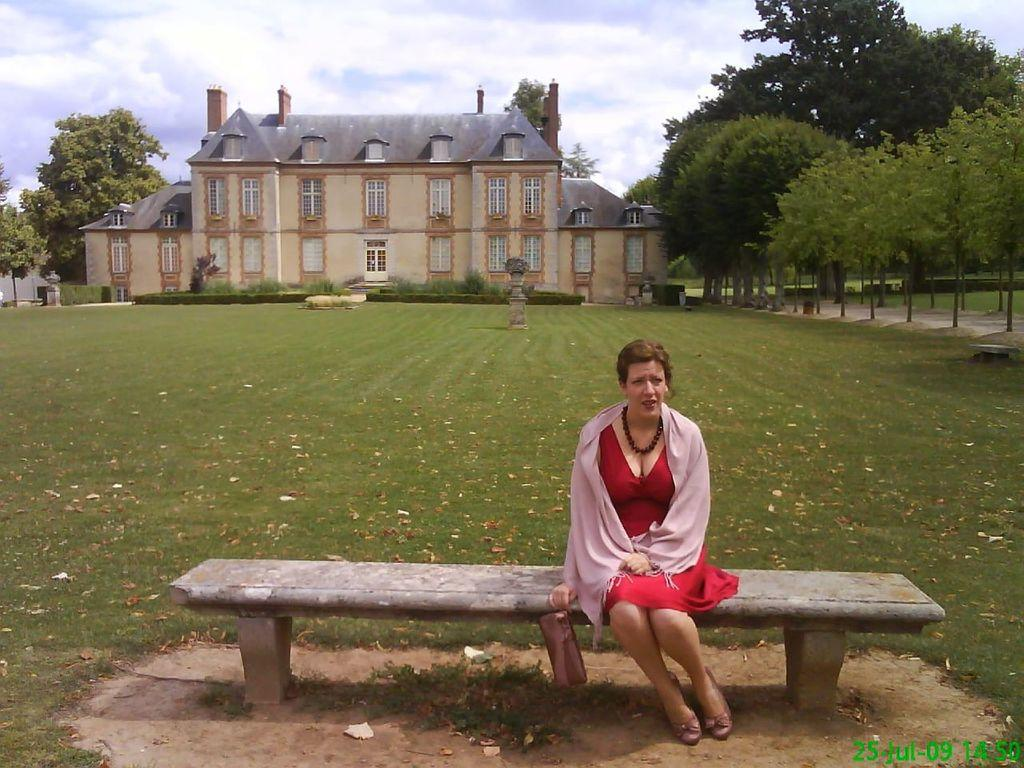What is the main subject in the foreground of the image? There is a woman sitting on a bench in the foreground of the image. What can be seen in the background of the image? There are trees, a building, and the sky visible in the background of the image. What type of calculator is the woman using in the image? There is no calculator present in the image. What phase of the moon can be seen in the image? The moon is not visible in the image; only the sky is visible in the background. 